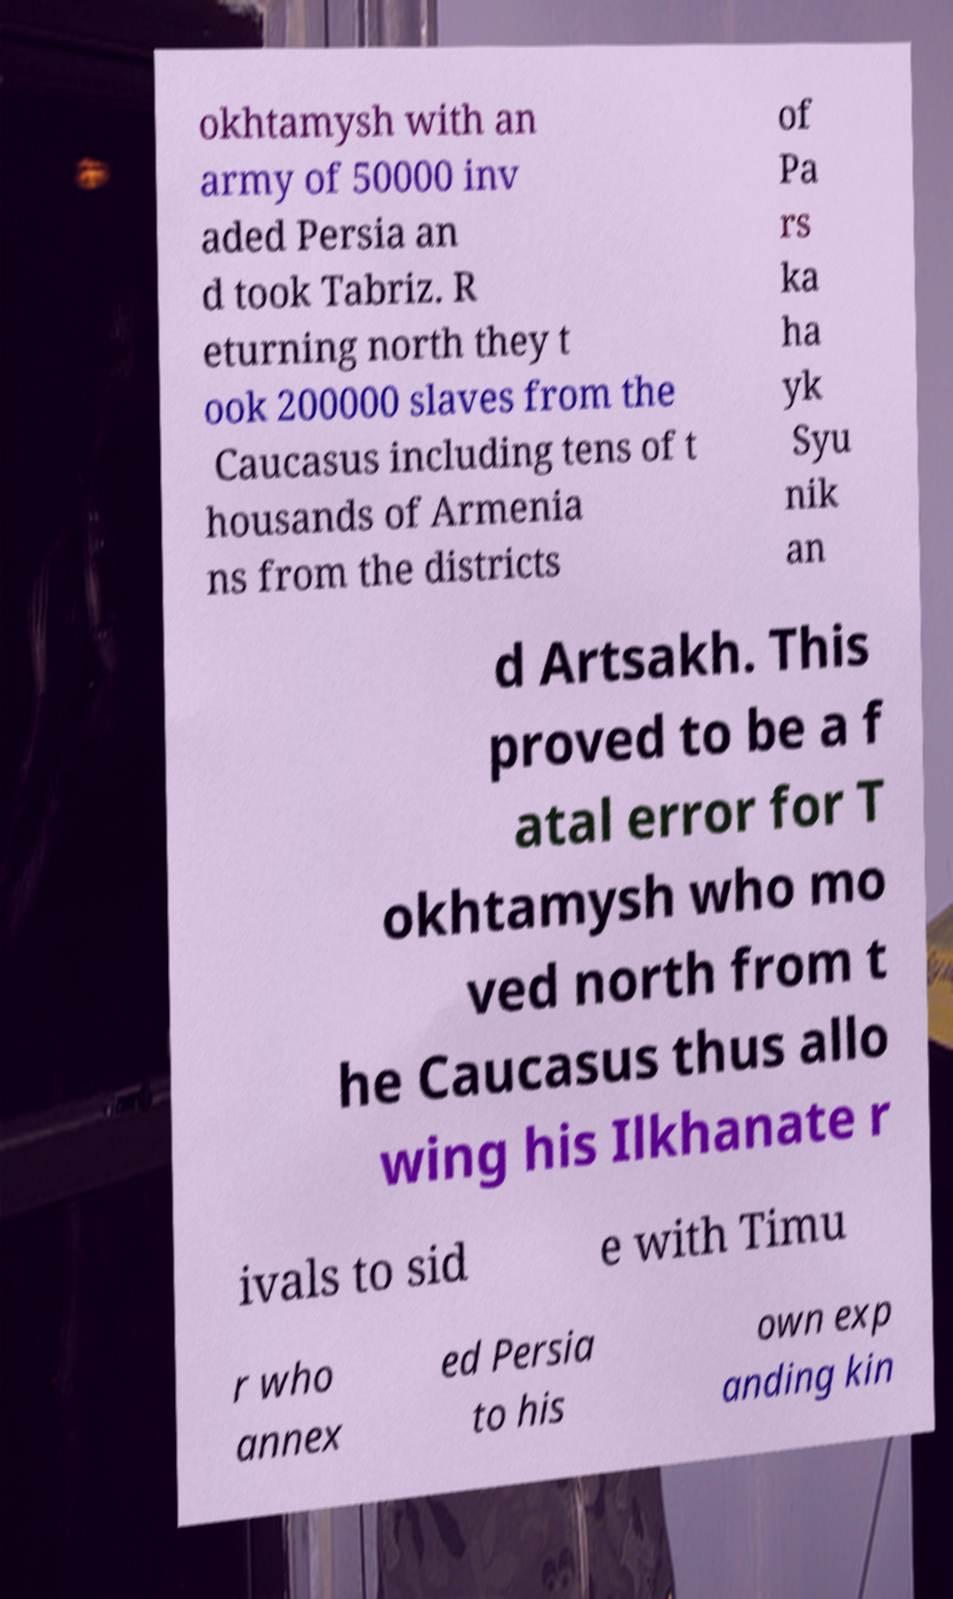Could you assist in decoding the text presented in this image and type it out clearly? okhtamysh with an army of 50000 inv aded Persia an d took Tabriz. R eturning north they t ook 200000 slaves from the Caucasus including tens of t housands of Armenia ns from the districts of Pa rs ka ha yk Syu nik an d Artsakh. This proved to be a f atal error for T okhtamysh who mo ved north from t he Caucasus thus allo wing his Ilkhanate r ivals to sid e with Timu r who annex ed Persia to his own exp anding kin 